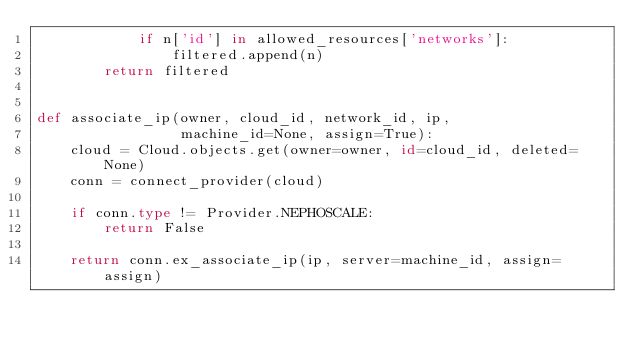<code> <loc_0><loc_0><loc_500><loc_500><_Python_>            if n['id'] in allowed_resources['networks']:
                filtered.append(n)
        return filtered


def associate_ip(owner, cloud_id, network_id, ip,
                 machine_id=None, assign=True):
    cloud = Cloud.objects.get(owner=owner, id=cloud_id, deleted=None)
    conn = connect_provider(cloud)

    if conn.type != Provider.NEPHOSCALE:
        return False

    return conn.ex_associate_ip(ip, server=machine_id, assign=assign)
</code> 